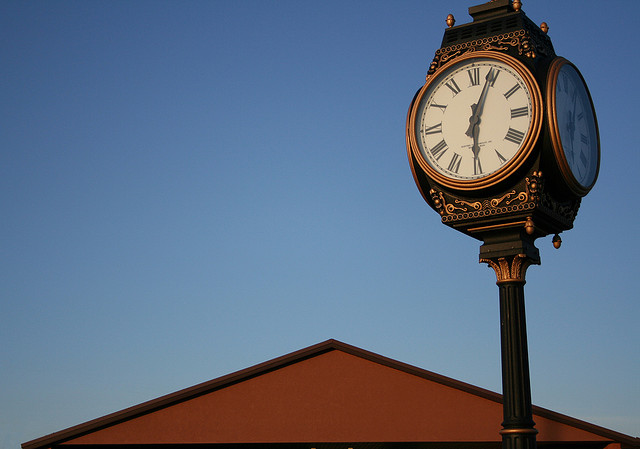Extract all visible text content from this image. XII II III III VII VIII V II 